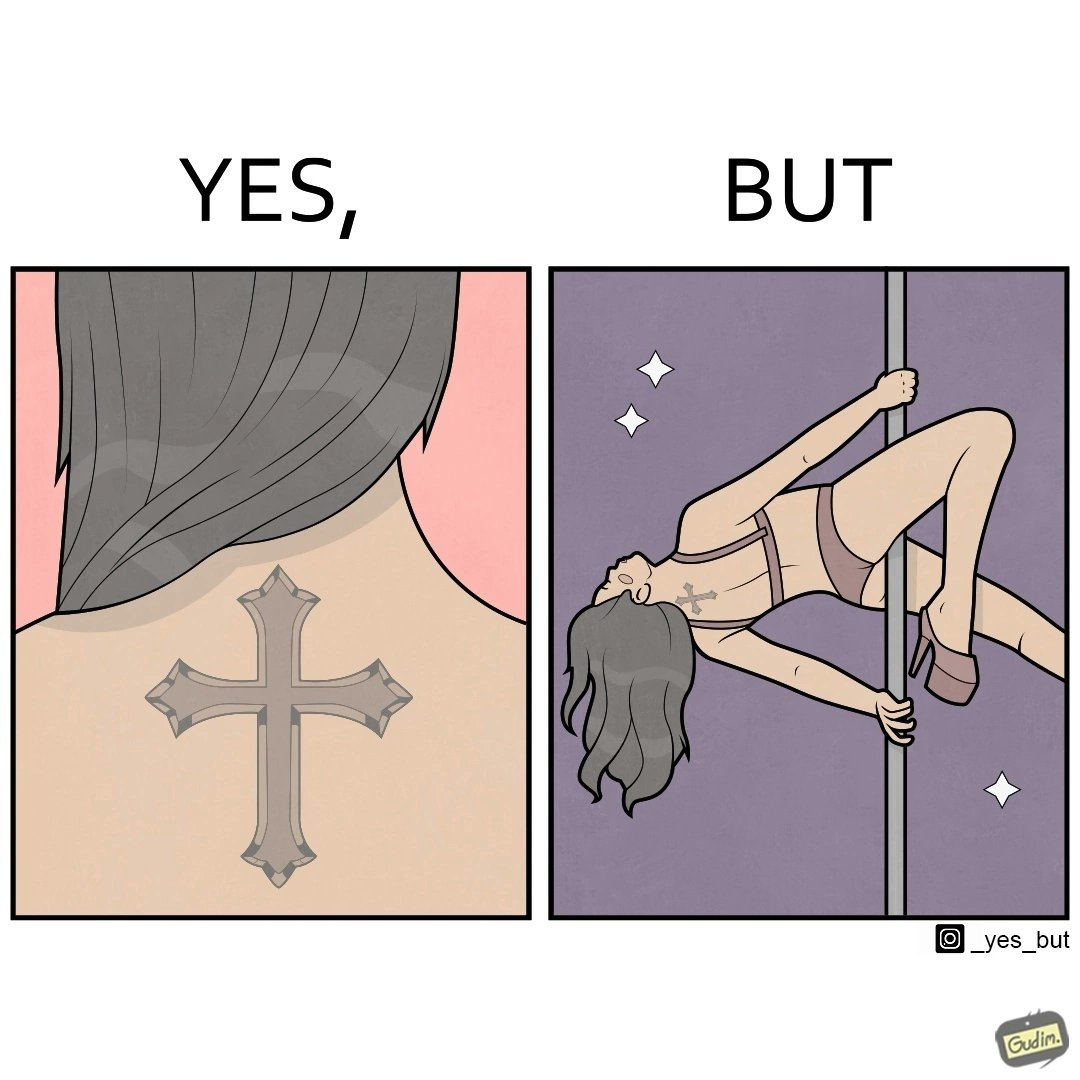What does this image depict? This image may present two different ideas, firstly even she is such a believer in god that she has got a tatto of holy cross symbol on her back but her situations have forced her to do a job at a bar or some place performing pole dance and secondly she is using a religious symbol to glorify her look so that more people acknowledge her dance and give her some money 